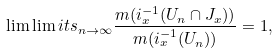<formula> <loc_0><loc_0><loc_500><loc_500>\lim \lim i t s _ { n \rightarrow \infty } \frac { m ( i _ { x } ^ { - 1 } ( U _ { n } \cap J _ { x } ) ) } { m ( i _ { x } ^ { - 1 } ( U _ { n } ) ) } = 1 , \</formula> 